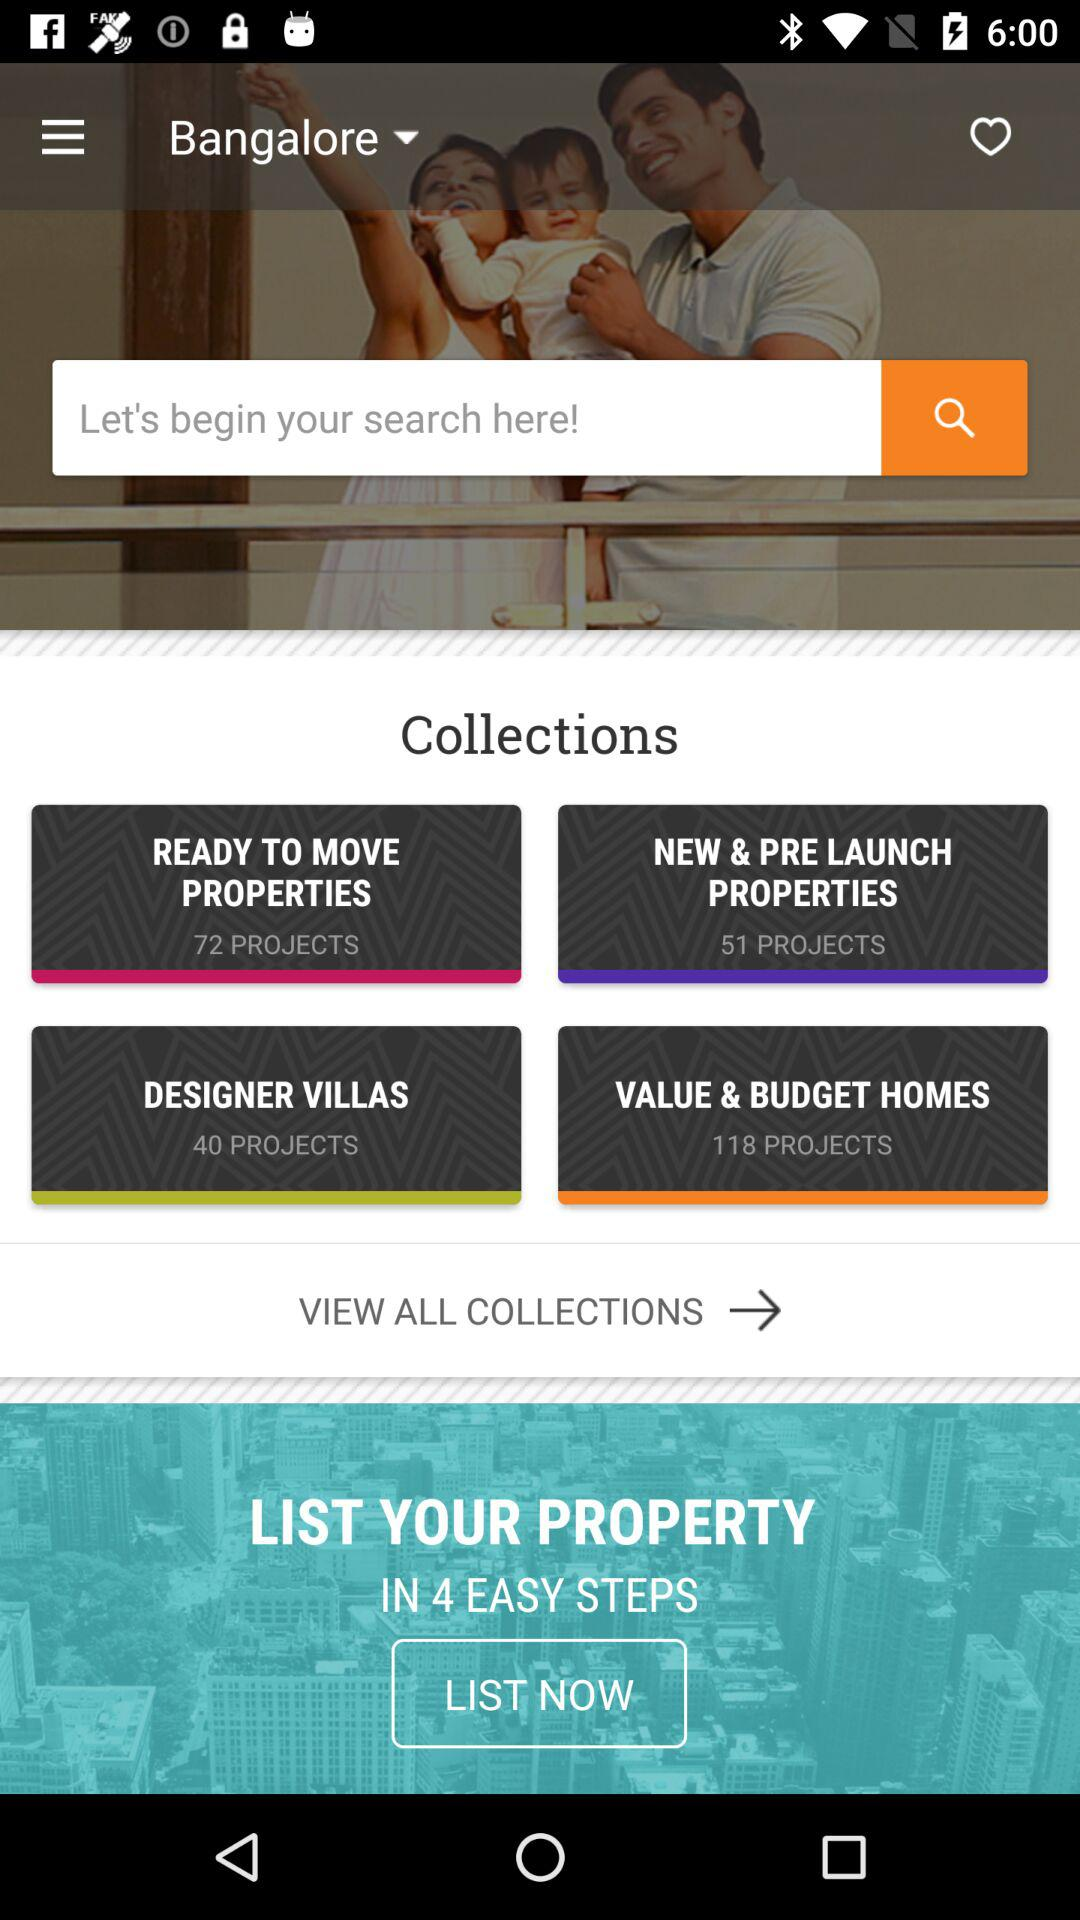How many more projects are there in the 'New & Pre Launch Properties' collection than in the 'Designer Villas' collection?
Answer the question using a single word or phrase. 11 